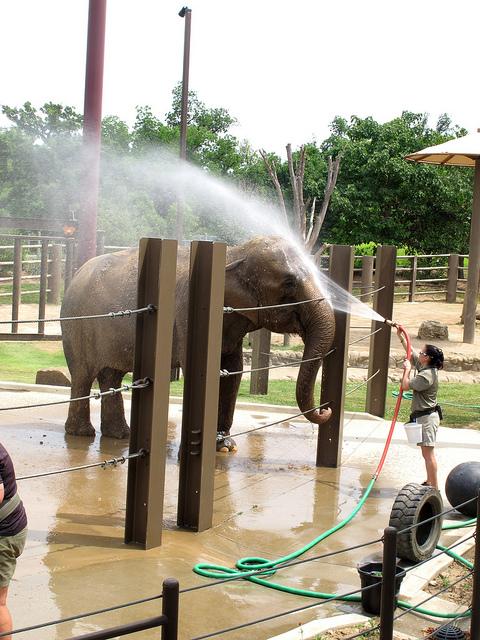Is the elephant at the zoo?
Keep it brief. Yes. How many water hose connected?
Keep it brief. 2. Why is the elephant being sprayed with a hose?
Keep it brief. Yes. 